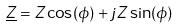<formula> <loc_0><loc_0><loc_500><loc_500>\underline { Z } = Z \cos ( \phi ) + j Z \sin ( \phi )</formula> 